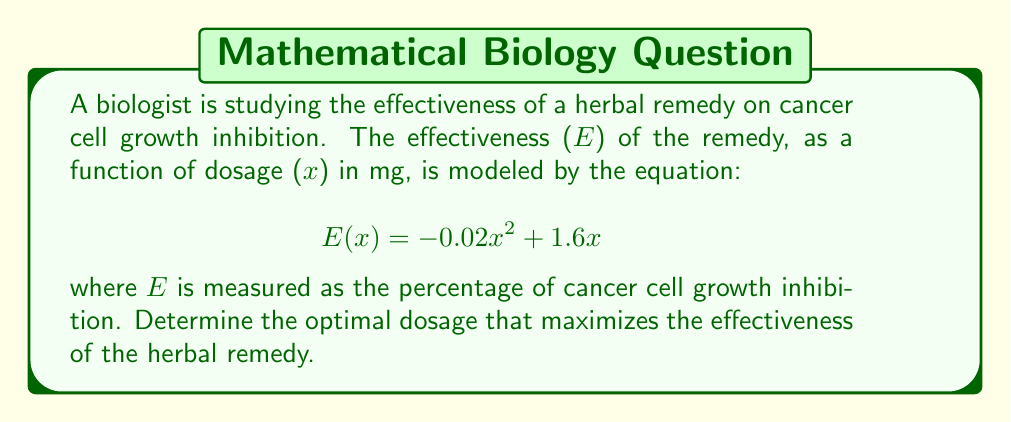Teach me how to tackle this problem. To find the optimal dosage that maximizes the effectiveness, we need to find the maximum of the function E(x). This can be done using calculus by following these steps:

1. Find the derivative of E(x):
   $$ \frac{d}{dx}E(x) = \frac{d}{dx}(-0.02x^2 + 1.6x) = -0.04x + 1.6 $$

2. Set the derivative equal to zero and solve for x:
   $$ -0.04x + 1.6 = 0 $$
   $$ -0.04x = -1.6 $$
   $$ x = \frac{-1.6}{-0.04} = 40 $$

3. Verify that this critical point is a maximum by checking the second derivative:
   $$ \frac{d^2}{dx^2}E(x) = -0.04 $$
   Since the second derivative is negative, the critical point is indeed a maximum.

4. Calculate the maximum effectiveness:
   $$ E(40) = -0.02(40)^2 + 1.6(40) = -32 + 64 = 32 $$

Therefore, the optimal dosage is 40 mg, which results in a maximum effectiveness of 32% cancer cell growth inhibition.
Answer: The optimal dosage is 40 mg. 